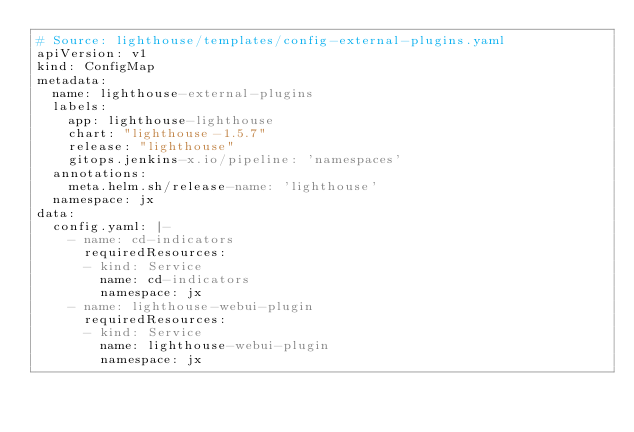Convert code to text. <code><loc_0><loc_0><loc_500><loc_500><_YAML_># Source: lighthouse/templates/config-external-plugins.yaml
apiVersion: v1
kind: ConfigMap
metadata:
  name: lighthouse-external-plugins
  labels:
    app: lighthouse-lighthouse
    chart: "lighthouse-1.5.7"
    release: "lighthouse"
    gitops.jenkins-x.io/pipeline: 'namespaces'
  annotations:
    meta.helm.sh/release-name: 'lighthouse'
  namespace: jx
data:
  config.yaml: |-
    - name: cd-indicators
      requiredResources:
      - kind: Service
        name: cd-indicators
        namespace: jx
    - name: lighthouse-webui-plugin
      requiredResources:
      - kind: Service
        name: lighthouse-webui-plugin
        namespace: jx
</code> 